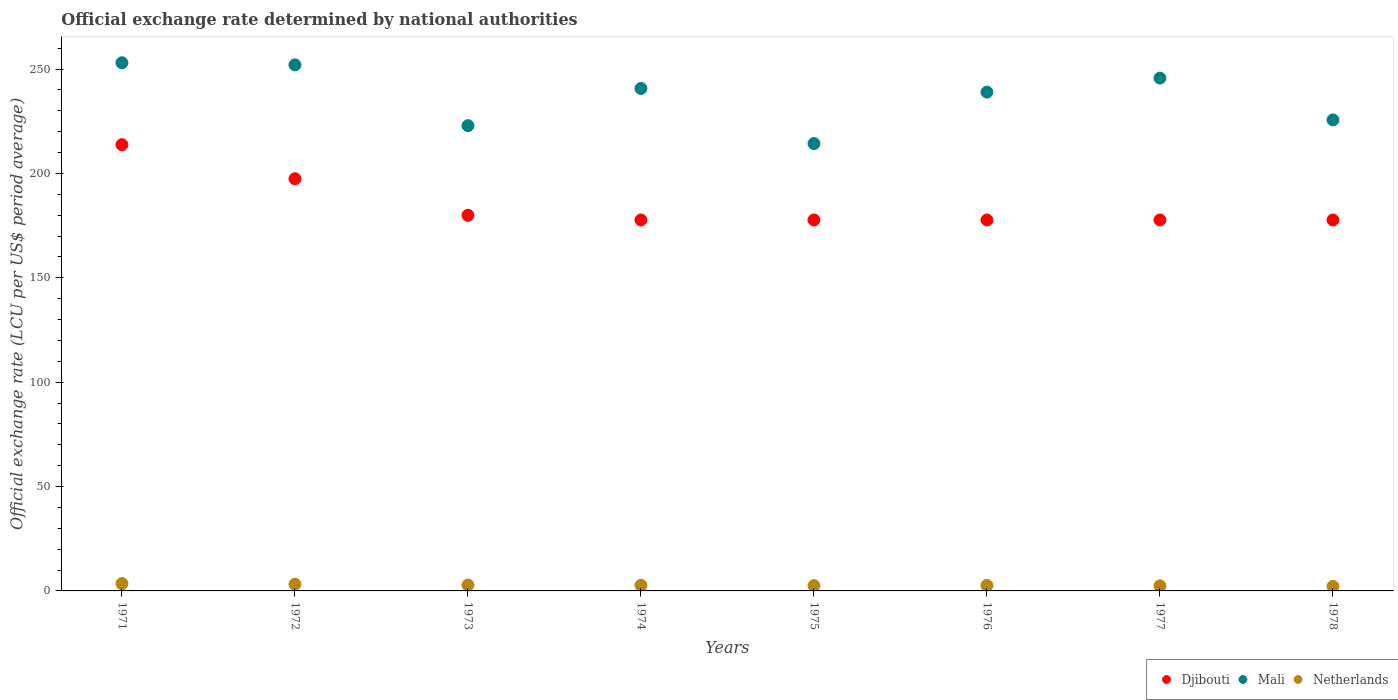How many different coloured dotlines are there?
Give a very brief answer. 3. What is the official exchange rate in Djibouti in 1975?
Make the answer very short. 177.72. Across all years, what is the maximum official exchange rate in Netherlands?
Provide a short and direct response. 3.52. Across all years, what is the minimum official exchange rate in Djibouti?
Ensure brevity in your answer.  177.72. In which year was the official exchange rate in Mali minimum?
Keep it short and to the point. 1975. What is the total official exchange rate in Netherlands in the graph?
Your response must be concise. 22. What is the difference between the official exchange rate in Djibouti in 1975 and the official exchange rate in Netherlands in 1974?
Make the answer very short. 175.03. What is the average official exchange rate in Netherlands per year?
Keep it short and to the point. 2.75. In the year 1971, what is the difference between the official exchange rate in Djibouti and official exchange rate in Netherlands?
Provide a short and direct response. 210.26. What is the ratio of the official exchange rate in Djibouti in 1972 to that in 1976?
Make the answer very short. 1.11. What is the difference between the highest and the second highest official exchange rate in Mali?
Ensure brevity in your answer.  1. What is the difference between the highest and the lowest official exchange rate in Djibouti?
Ensure brevity in your answer.  36.06. Is the sum of the official exchange rate in Djibouti in 1973 and 1977 greater than the maximum official exchange rate in Mali across all years?
Offer a very short reply. Yes. Does the official exchange rate in Netherlands monotonically increase over the years?
Keep it short and to the point. No. Is the official exchange rate in Mali strictly greater than the official exchange rate in Djibouti over the years?
Make the answer very short. Yes. Is the official exchange rate in Djibouti strictly less than the official exchange rate in Netherlands over the years?
Keep it short and to the point. No. How many years are there in the graph?
Provide a short and direct response. 8. What is the difference between two consecutive major ticks on the Y-axis?
Offer a terse response. 50. Does the graph contain any zero values?
Give a very brief answer. No. Does the graph contain grids?
Ensure brevity in your answer.  No. Where does the legend appear in the graph?
Your answer should be very brief. Bottom right. How many legend labels are there?
Your answer should be compact. 3. How are the legend labels stacked?
Your answer should be very brief. Horizontal. What is the title of the graph?
Keep it short and to the point. Official exchange rate determined by national authorities. What is the label or title of the X-axis?
Provide a short and direct response. Years. What is the label or title of the Y-axis?
Offer a very short reply. Official exchange rate (LCU per US$ period average). What is the Official exchange rate (LCU per US$ period average) in Djibouti in 1971?
Provide a succinct answer. 213.78. What is the Official exchange rate (LCU per US$ period average) of Mali in 1971?
Your answer should be very brief. 253.03. What is the Official exchange rate (LCU per US$ period average) of Netherlands in 1971?
Your answer should be compact. 3.52. What is the Official exchange rate (LCU per US$ period average) of Djibouti in 1972?
Ensure brevity in your answer.  197.47. What is the Official exchange rate (LCU per US$ period average) of Mali in 1972?
Provide a short and direct response. 252.03. What is the Official exchange rate (LCU per US$ period average) of Netherlands in 1972?
Provide a short and direct response. 3.21. What is the Official exchange rate (LCU per US$ period average) in Djibouti in 1973?
Ensure brevity in your answer.  179.94. What is the Official exchange rate (LCU per US$ period average) of Mali in 1973?
Give a very brief answer. 222.89. What is the Official exchange rate (LCU per US$ period average) of Netherlands in 1973?
Keep it short and to the point. 2.8. What is the Official exchange rate (LCU per US$ period average) of Djibouti in 1974?
Your response must be concise. 177.72. What is the Official exchange rate (LCU per US$ period average) of Mali in 1974?
Ensure brevity in your answer.  240.7. What is the Official exchange rate (LCU per US$ period average) in Netherlands in 1974?
Provide a succinct answer. 2.69. What is the Official exchange rate (LCU per US$ period average) of Djibouti in 1975?
Give a very brief answer. 177.72. What is the Official exchange rate (LCU per US$ period average) of Mali in 1975?
Your response must be concise. 214.31. What is the Official exchange rate (LCU per US$ period average) of Netherlands in 1975?
Your answer should be very brief. 2.53. What is the Official exchange rate (LCU per US$ period average) of Djibouti in 1976?
Your answer should be very brief. 177.72. What is the Official exchange rate (LCU per US$ period average) in Mali in 1976?
Give a very brief answer. 238.95. What is the Official exchange rate (LCU per US$ period average) of Netherlands in 1976?
Provide a succinct answer. 2.64. What is the Official exchange rate (LCU per US$ period average) in Djibouti in 1977?
Provide a succinct answer. 177.72. What is the Official exchange rate (LCU per US$ period average) of Mali in 1977?
Your answer should be compact. 245.68. What is the Official exchange rate (LCU per US$ period average) of Netherlands in 1977?
Provide a short and direct response. 2.45. What is the Official exchange rate (LCU per US$ period average) in Djibouti in 1978?
Give a very brief answer. 177.72. What is the Official exchange rate (LCU per US$ period average) of Mali in 1978?
Make the answer very short. 225.66. What is the Official exchange rate (LCU per US$ period average) of Netherlands in 1978?
Your response must be concise. 2.16. Across all years, what is the maximum Official exchange rate (LCU per US$ period average) of Djibouti?
Keep it short and to the point. 213.78. Across all years, what is the maximum Official exchange rate (LCU per US$ period average) in Mali?
Your answer should be very brief. 253.03. Across all years, what is the maximum Official exchange rate (LCU per US$ period average) of Netherlands?
Give a very brief answer. 3.52. Across all years, what is the minimum Official exchange rate (LCU per US$ period average) of Djibouti?
Ensure brevity in your answer.  177.72. Across all years, what is the minimum Official exchange rate (LCU per US$ period average) in Mali?
Offer a terse response. 214.31. Across all years, what is the minimum Official exchange rate (LCU per US$ period average) in Netherlands?
Offer a terse response. 2.16. What is the total Official exchange rate (LCU per US$ period average) of Djibouti in the graph?
Your answer should be very brief. 1479.79. What is the total Official exchange rate (LCU per US$ period average) of Mali in the graph?
Offer a terse response. 1893.25. What is the total Official exchange rate (LCU per US$ period average) of Netherlands in the graph?
Ensure brevity in your answer.  22. What is the difference between the Official exchange rate (LCU per US$ period average) of Djibouti in 1971 and that in 1972?
Ensure brevity in your answer.  16.31. What is the difference between the Official exchange rate (LCU per US$ period average) of Netherlands in 1971 and that in 1972?
Make the answer very short. 0.31. What is the difference between the Official exchange rate (LCU per US$ period average) in Djibouti in 1971 and that in 1973?
Your answer should be compact. 33.84. What is the difference between the Official exchange rate (LCU per US$ period average) of Mali in 1971 and that in 1973?
Keep it short and to the point. 30.14. What is the difference between the Official exchange rate (LCU per US$ period average) in Netherlands in 1971 and that in 1973?
Ensure brevity in your answer.  0.72. What is the difference between the Official exchange rate (LCU per US$ period average) of Djibouti in 1971 and that in 1974?
Make the answer very short. 36.06. What is the difference between the Official exchange rate (LCU per US$ period average) in Mali in 1971 and that in 1974?
Provide a short and direct response. 12.32. What is the difference between the Official exchange rate (LCU per US$ period average) in Netherlands in 1971 and that in 1974?
Provide a succinct answer. 0.83. What is the difference between the Official exchange rate (LCU per US$ period average) in Djibouti in 1971 and that in 1975?
Make the answer very short. 36.06. What is the difference between the Official exchange rate (LCU per US$ period average) of Mali in 1971 and that in 1975?
Offer a terse response. 38.71. What is the difference between the Official exchange rate (LCU per US$ period average) of Djibouti in 1971 and that in 1976?
Provide a short and direct response. 36.06. What is the difference between the Official exchange rate (LCU per US$ period average) in Mali in 1971 and that in 1976?
Offer a very short reply. 14.08. What is the difference between the Official exchange rate (LCU per US$ period average) in Netherlands in 1971 and that in 1976?
Provide a short and direct response. 0.87. What is the difference between the Official exchange rate (LCU per US$ period average) of Djibouti in 1971 and that in 1977?
Your response must be concise. 36.06. What is the difference between the Official exchange rate (LCU per US$ period average) in Mali in 1971 and that in 1977?
Offer a terse response. 7.35. What is the difference between the Official exchange rate (LCU per US$ period average) of Netherlands in 1971 and that in 1977?
Provide a succinct answer. 1.06. What is the difference between the Official exchange rate (LCU per US$ period average) of Djibouti in 1971 and that in 1978?
Your answer should be compact. 36.06. What is the difference between the Official exchange rate (LCU per US$ period average) of Mali in 1971 and that in 1978?
Your answer should be compact. 27.37. What is the difference between the Official exchange rate (LCU per US$ period average) in Netherlands in 1971 and that in 1978?
Your answer should be compact. 1.35. What is the difference between the Official exchange rate (LCU per US$ period average) of Djibouti in 1972 and that in 1973?
Make the answer very short. 17.52. What is the difference between the Official exchange rate (LCU per US$ period average) of Mali in 1972 and that in 1973?
Keep it short and to the point. 29.14. What is the difference between the Official exchange rate (LCU per US$ period average) in Netherlands in 1972 and that in 1973?
Offer a very short reply. 0.41. What is the difference between the Official exchange rate (LCU per US$ period average) in Djibouti in 1972 and that in 1974?
Give a very brief answer. 19.75. What is the difference between the Official exchange rate (LCU per US$ period average) of Mali in 1972 and that in 1974?
Your answer should be compact. 11.32. What is the difference between the Official exchange rate (LCU per US$ period average) in Netherlands in 1972 and that in 1974?
Provide a short and direct response. 0.52. What is the difference between the Official exchange rate (LCU per US$ period average) of Djibouti in 1972 and that in 1975?
Ensure brevity in your answer.  19.75. What is the difference between the Official exchange rate (LCU per US$ period average) in Mali in 1972 and that in 1975?
Your response must be concise. 37.71. What is the difference between the Official exchange rate (LCU per US$ period average) in Netherlands in 1972 and that in 1975?
Provide a succinct answer. 0.68. What is the difference between the Official exchange rate (LCU per US$ period average) of Djibouti in 1972 and that in 1976?
Make the answer very short. 19.75. What is the difference between the Official exchange rate (LCU per US$ period average) in Mali in 1972 and that in 1976?
Provide a short and direct response. 13.08. What is the difference between the Official exchange rate (LCU per US$ period average) of Netherlands in 1972 and that in 1976?
Your answer should be compact. 0.57. What is the difference between the Official exchange rate (LCU per US$ period average) in Djibouti in 1972 and that in 1977?
Provide a short and direct response. 19.75. What is the difference between the Official exchange rate (LCU per US$ period average) of Mali in 1972 and that in 1977?
Provide a succinct answer. 6.35. What is the difference between the Official exchange rate (LCU per US$ period average) in Netherlands in 1972 and that in 1977?
Provide a succinct answer. 0.76. What is the difference between the Official exchange rate (LCU per US$ period average) of Djibouti in 1972 and that in 1978?
Keep it short and to the point. 19.75. What is the difference between the Official exchange rate (LCU per US$ period average) of Mali in 1972 and that in 1978?
Offer a very short reply. 26.37. What is the difference between the Official exchange rate (LCU per US$ period average) in Netherlands in 1972 and that in 1978?
Keep it short and to the point. 1.05. What is the difference between the Official exchange rate (LCU per US$ period average) of Djibouti in 1973 and that in 1974?
Offer a very short reply. 2.22. What is the difference between the Official exchange rate (LCU per US$ period average) in Mali in 1973 and that in 1974?
Make the answer very short. -17.82. What is the difference between the Official exchange rate (LCU per US$ period average) in Netherlands in 1973 and that in 1974?
Your answer should be very brief. 0.11. What is the difference between the Official exchange rate (LCU per US$ period average) of Djibouti in 1973 and that in 1975?
Ensure brevity in your answer.  2.22. What is the difference between the Official exchange rate (LCU per US$ period average) in Mali in 1973 and that in 1975?
Offer a terse response. 8.58. What is the difference between the Official exchange rate (LCU per US$ period average) of Netherlands in 1973 and that in 1975?
Offer a terse response. 0.27. What is the difference between the Official exchange rate (LCU per US$ period average) in Djibouti in 1973 and that in 1976?
Offer a very short reply. 2.22. What is the difference between the Official exchange rate (LCU per US$ period average) of Mali in 1973 and that in 1976?
Provide a succinct answer. -16.06. What is the difference between the Official exchange rate (LCU per US$ period average) in Netherlands in 1973 and that in 1976?
Your answer should be compact. 0.15. What is the difference between the Official exchange rate (LCU per US$ period average) in Djibouti in 1973 and that in 1977?
Your answer should be compact. 2.22. What is the difference between the Official exchange rate (LCU per US$ period average) of Mali in 1973 and that in 1977?
Your answer should be very brief. -22.79. What is the difference between the Official exchange rate (LCU per US$ period average) in Netherlands in 1973 and that in 1977?
Provide a succinct answer. 0.34. What is the difference between the Official exchange rate (LCU per US$ period average) of Djibouti in 1973 and that in 1978?
Offer a terse response. 2.22. What is the difference between the Official exchange rate (LCU per US$ period average) in Mali in 1973 and that in 1978?
Offer a very short reply. -2.77. What is the difference between the Official exchange rate (LCU per US$ period average) of Netherlands in 1973 and that in 1978?
Offer a terse response. 0.63. What is the difference between the Official exchange rate (LCU per US$ period average) in Djibouti in 1974 and that in 1975?
Your answer should be compact. 0. What is the difference between the Official exchange rate (LCU per US$ period average) in Mali in 1974 and that in 1975?
Offer a terse response. 26.39. What is the difference between the Official exchange rate (LCU per US$ period average) of Netherlands in 1974 and that in 1975?
Ensure brevity in your answer.  0.16. What is the difference between the Official exchange rate (LCU per US$ period average) of Djibouti in 1974 and that in 1976?
Offer a terse response. 0. What is the difference between the Official exchange rate (LCU per US$ period average) in Mali in 1974 and that in 1976?
Make the answer very short. 1.75. What is the difference between the Official exchange rate (LCU per US$ period average) of Netherlands in 1974 and that in 1976?
Offer a very short reply. 0.04. What is the difference between the Official exchange rate (LCU per US$ period average) of Mali in 1974 and that in 1977?
Provide a succinct answer. -4.97. What is the difference between the Official exchange rate (LCU per US$ period average) of Netherlands in 1974 and that in 1977?
Your response must be concise. 0.23. What is the difference between the Official exchange rate (LCU per US$ period average) of Djibouti in 1974 and that in 1978?
Provide a short and direct response. 0. What is the difference between the Official exchange rate (LCU per US$ period average) of Mali in 1974 and that in 1978?
Ensure brevity in your answer.  15.05. What is the difference between the Official exchange rate (LCU per US$ period average) in Netherlands in 1974 and that in 1978?
Your answer should be compact. 0.52. What is the difference between the Official exchange rate (LCU per US$ period average) in Mali in 1975 and that in 1976?
Keep it short and to the point. -24.64. What is the difference between the Official exchange rate (LCU per US$ period average) in Netherlands in 1975 and that in 1976?
Your answer should be very brief. -0.11. What is the difference between the Official exchange rate (LCU per US$ period average) of Mali in 1975 and that in 1977?
Keep it short and to the point. -31.37. What is the difference between the Official exchange rate (LCU per US$ period average) in Netherlands in 1975 and that in 1977?
Ensure brevity in your answer.  0.07. What is the difference between the Official exchange rate (LCU per US$ period average) in Mali in 1975 and that in 1978?
Give a very brief answer. -11.34. What is the difference between the Official exchange rate (LCU per US$ period average) of Netherlands in 1975 and that in 1978?
Give a very brief answer. 0.37. What is the difference between the Official exchange rate (LCU per US$ period average) in Mali in 1976 and that in 1977?
Offer a very short reply. -6.73. What is the difference between the Official exchange rate (LCU per US$ period average) of Netherlands in 1976 and that in 1977?
Keep it short and to the point. 0.19. What is the difference between the Official exchange rate (LCU per US$ period average) of Djibouti in 1976 and that in 1978?
Offer a terse response. 0. What is the difference between the Official exchange rate (LCU per US$ period average) of Mali in 1976 and that in 1978?
Provide a succinct answer. 13.29. What is the difference between the Official exchange rate (LCU per US$ period average) in Netherlands in 1976 and that in 1978?
Make the answer very short. 0.48. What is the difference between the Official exchange rate (LCU per US$ period average) of Djibouti in 1977 and that in 1978?
Ensure brevity in your answer.  0. What is the difference between the Official exchange rate (LCU per US$ period average) of Mali in 1977 and that in 1978?
Offer a terse response. 20.02. What is the difference between the Official exchange rate (LCU per US$ period average) of Netherlands in 1977 and that in 1978?
Make the answer very short. 0.29. What is the difference between the Official exchange rate (LCU per US$ period average) of Djibouti in 1971 and the Official exchange rate (LCU per US$ period average) of Mali in 1972?
Your answer should be very brief. -38.25. What is the difference between the Official exchange rate (LCU per US$ period average) in Djibouti in 1971 and the Official exchange rate (LCU per US$ period average) in Netherlands in 1972?
Your answer should be very brief. 210.57. What is the difference between the Official exchange rate (LCU per US$ period average) of Mali in 1971 and the Official exchange rate (LCU per US$ period average) of Netherlands in 1972?
Offer a very short reply. 249.82. What is the difference between the Official exchange rate (LCU per US$ period average) of Djibouti in 1971 and the Official exchange rate (LCU per US$ period average) of Mali in 1973?
Keep it short and to the point. -9.11. What is the difference between the Official exchange rate (LCU per US$ period average) in Djibouti in 1971 and the Official exchange rate (LCU per US$ period average) in Netherlands in 1973?
Provide a succinct answer. 210.98. What is the difference between the Official exchange rate (LCU per US$ period average) in Mali in 1971 and the Official exchange rate (LCU per US$ period average) in Netherlands in 1973?
Give a very brief answer. 250.23. What is the difference between the Official exchange rate (LCU per US$ period average) in Djibouti in 1971 and the Official exchange rate (LCU per US$ period average) in Mali in 1974?
Provide a succinct answer. -26.93. What is the difference between the Official exchange rate (LCU per US$ period average) of Djibouti in 1971 and the Official exchange rate (LCU per US$ period average) of Netherlands in 1974?
Offer a terse response. 211.09. What is the difference between the Official exchange rate (LCU per US$ period average) in Mali in 1971 and the Official exchange rate (LCU per US$ period average) in Netherlands in 1974?
Give a very brief answer. 250.34. What is the difference between the Official exchange rate (LCU per US$ period average) of Djibouti in 1971 and the Official exchange rate (LCU per US$ period average) of Mali in 1975?
Your response must be concise. -0.53. What is the difference between the Official exchange rate (LCU per US$ period average) of Djibouti in 1971 and the Official exchange rate (LCU per US$ period average) of Netherlands in 1975?
Give a very brief answer. 211.25. What is the difference between the Official exchange rate (LCU per US$ period average) of Mali in 1971 and the Official exchange rate (LCU per US$ period average) of Netherlands in 1975?
Offer a terse response. 250.5. What is the difference between the Official exchange rate (LCU per US$ period average) of Djibouti in 1971 and the Official exchange rate (LCU per US$ period average) of Mali in 1976?
Your answer should be compact. -25.17. What is the difference between the Official exchange rate (LCU per US$ period average) in Djibouti in 1971 and the Official exchange rate (LCU per US$ period average) in Netherlands in 1976?
Your response must be concise. 211.13. What is the difference between the Official exchange rate (LCU per US$ period average) in Mali in 1971 and the Official exchange rate (LCU per US$ period average) in Netherlands in 1976?
Keep it short and to the point. 250.38. What is the difference between the Official exchange rate (LCU per US$ period average) in Djibouti in 1971 and the Official exchange rate (LCU per US$ period average) in Mali in 1977?
Keep it short and to the point. -31.9. What is the difference between the Official exchange rate (LCU per US$ period average) in Djibouti in 1971 and the Official exchange rate (LCU per US$ period average) in Netherlands in 1977?
Provide a succinct answer. 211.32. What is the difference between the Official exchange rate (LCU per US$ period average) of Mali in 1971 and the Official exchange rate (LCU per US$ period average) of Netherlands in 1977?
Give a very brief answer. 250.57. What is the difference between the Official exchange rate (LCU per US$ period average) of Djibouti in 1971 and the Official exchange rate (LCU per US$ period average) of Mali in 1978?
Ensure brevity in your answer.  -11.88. What is the difference between the Official exchange rate (LCU per US$ period average) in Djibouti in 1971 and the Official exchange rate (LCU per US$ period average) in Netherlands in 1978?
Ensure brevity in your answer.  211.62. What is the difference between the Official exchange rate (LCU per US$ period average) in Mali in 1971 and the Official exchange rate (LCU per US$ period average) in Netherlands in 1978?
Offer a terse response. 250.86. What is the difference between the Official exchange rate (LCU per US$ period average) of Djibouti in 1972 and the Official exchange rate (LCU per US$ period average) of Mali in 1973?
Offer a terse response. -25.42. What is the difference between the Official exchange rate (LCU per US$ period average) of Djibouti in 1972 and the Official exchange rate (LCU per US$ period average) of Netherlands in 1973?
Ensure brevity in your answer.  194.67. What is the difference between the Official exchange rate (LCU per US$ period average) of Mali in 1972 and the Official exchange rate (LCU per US$ period average) of Netherlands in 1973?
Make the answer very short. 249.23. What is the difference between the Official exchange rate (LCU per US$ period average) of Djibouti in 1972 and the Official exchange rate (LCU per US$ period average) of Mali in 1974?
Make the answer very short. -43.24. What is the difference between the Official exchange rate (LCU per US$ period average) of Djibouti in 1972 and the Official exchange rate (LCU per US$ period average) of Netherlands in 1974?
Ensure brevity in your answer.  194.78. What is the difference between the Official exchange rate (LCU per US$ period average) in Mali in 1972 and the Official exchange rate (LCU per US$ period average) in Netherlands in 1974?
Give a very brief answer. 249.34. What is the difference between the Official exchange rate (LCU per US$ period average) of Djibouti in 1972 and the Official exchange rate (LCU per US$ period average) of Mali in 1975?
Your answer should be compact. -16.85. What is the difference between the Official exchange rate (LCU per US$ period average) in Djibouti in 1972 and the Official exchange rate (LCU per US$ period average) in Netherlands in 1975?
Provide a short and direct response. 194.94. What is the difference between the Official exchange rate (LCU per US$ period average) of Mali in 1972 and the Official exchange rate (LCU per US$ period average) of Netherlands in 1975?
Offer a terse response. 249.5. What is the difference between the Official exchange rate (LCU per US$ period average) of Djibouti in 1972 and the Official exchange rate (LCU per US$ period average) of Mali in 1976?
Your answer should be very brief. -41.48. What is the difference between the Official exchange rate (LCU per US$ period average) in Djibouti in 1972 and the Official exchange rate (LCU per US$ period average) in Netherlands in 1976?
Offer a terse response. 194.82. What is the difference between the Official exchange rate (LCU per US$ period average) of Mali in 1972 and the Official exchange rate (LCU per US$ period average) of Netherlands in 1976?
Offer a very short reply. 249.38. What is the difference between the Official exchange rate (LCU per US$ period average) of Djibouti in 1972 and the Official exchange rate (LCU per US$ period average) of Mali in 1977?
Your answer should be compact. -48.21. What is the difference between the Official exchange rate (LCU per US$ period average) of Djibouti in 1972 and the Official exchange rate (LCU per US$ period average) of Netherlands in 1977?
Make the answer very short. 195.01. What is the difference between the Official exchange rate (LCU per US$ period average) in Mali in 1972 and the Official exchange rate (LCU per US$ period average) in Netherlands in 1977?
Provide a short and direct response. 249.57. What is the difference between the Official exchange rate (LCU per US$ period average) in Djibouti in 1972 and the Official exchange rate (LCU per US$ period average) in Mali in 1978?
Offer a very short reply. -28.19. What is the difference between the Official exchange rate (LCU per US$ period average) of Djibouti in 1972 and the Official exchange rate (LCU per US$ period average) of Netherlands in 1978?
Keep it short and to the point. 195.3. What is the difference between the Official exchange rate (LCU per US$ period average) of Mali in 1972 and the Official exchange rate (LCU per US$ period average) of Netherlands in 1978?
Make the answer very short. 249.86. What is the difference between the Official exchange rate (LCU per US$ period average) in Djibouti in 1973 and the Official exchange rate (LCU per US$ period average) in Mali in 1974?
Provide a short and direct response. -60.76. What is the difference between the Official exchange rate (LCU per US$ period average) in Djibouti in 1973 and the Official exchange rate (LCU per US$ period average) in Netherlands in 1974?
Provide a short and direct response. 177.25. What is the difference between the Official exchange rate (LCU per US$ period average) in Mali in 1973 and the Official exchange rate (LCU per US$ period average) in Netherlands in 1974?
Ensure brevity in your answer.  220.2. What is the difference between the Official exchange rate (LCU per US$ period average) of Djibouti in 1973 and the Official exchange rate (LCU per US$ period average) of Mali in 1975?
Offer a very short reply. -34.37. What is the difference between the Official exchange rate (LCU per US$ period average) of Djibouti in 1973 and the Official exchange rate (LCU per US$ period average) of Netherlands in 1975?
Provide a succinct answer. 177.41. What is the difference between the Official exchange rate (LCU per US$ period average) in Mali in 1973 and the Official exchange rate (LCU per US$ period average) in Netherlands in 1975?
Your response must be concise. 220.36. What is the difference between the Official exchange rate (LCU per US$ period average) in Djibouti in 1973 and the Official exchange rate (LCU per US$ period average) in Mali in 1976?
Keep it short and to the point. -59.01. What is the difference between the Official exchange rate (LCU per US$ period average) in Djibouti in 1973 and the Official exchange rate (LCU per US$ period average) in Netherlands in 1976?
Offer a very short reply. 177.3. What is the difference between the Official exchange rate (LCU per US$ period average) of Mali in 1973 and the Official exchange rate (LCU per US$ period average) of Netherlands in 1976?
Provide a succinct answer. 220.25. What is the difference between the Official exchange rate (LCU per US$ period average) of Djibouti in 1973 and the Official exchange rate (LCU per US$ period average) of Mali in 1977?
Offer a very short reply. -65.74. What is the difference between the Official exchange rate (LCU per US$ period average) in Djibouti in 1973 and the Official exchange rate (LCU per US$ period average) in Netherlands in 1977?
Give a very brief answer. 177.49. What is the difference between the Official exchange rate (LCU per US$ period average) in Mali in 1973 and the Official exchange rate (LCU per US$ period average) in Netherlands in 1977?
Ensure brevity in your answer.  220.43. What is the difference between the Official exchange rate (LCU per US$ period average) in Djibouti in 1973 and the Official exchange rate (LCU per US$ period average) in Mali in 1978?
Provide a short and direct response. -45.71. What is the difference between the Official exchange rate (LCU per US$ period average) of Djibouti in 1973 and the Official exchange rate (LCU per US$ period average) of Netherlands in 1978?
Keep it short and to the point. 177.78. What is the difference between the Official exchange rate (LCU per US$ period average) in Mali in 1973 and the Official exchange rate (LCU per US$ period average) in Netherlands in 1978?
Keep it short and to the point. 220.73. What is the difference between the Official exchange rate (LCU per US$ period average) of Djibouti in 1974 and the Official exchange rate (LCU per US$ period average) of Mali in 1975?
Your answer should be compact. -36.59. What is the difference between the Official exchange rate (LCU per US$ period average) in Djibouti in 1974 and the Official exchange rate (LCU per US$ period average) in Netherlands in 1975?
Ensure brevity in your answer.  175.19. What is the difference between the Official exchange rate (LCU per US$ period average) in Mali in 1974 and the Official exchange rate (LCU per US$ period average) in Netherlands in 1975?
Your answer should be compact. 238.18. What is the difference between the Official exchange rate (LCU per US$ period average) of Djibouti in 1974 and the Official exchange rate (LCU per US$ period average) of Mali in 1976?
Make the answer very short. -61.23. What is the difference between the Official exchange rate (LCU per US$ period average) in Djibouti in 1974 and the Official exchange rate (LCU per US$ period average) in Netherlands in 1976?
Ensure brevity in your answer.  175.08. What is the difference between the Official exchange rate (LCU per US$ period average) of Mali in 1974 and the Official exchange rate (LCU per US$ period average) of Netherlands in 1976?
Offer a very short reply. 238.06. What is the difference between the Official exchange rate (LCU per US$ period average) in Djibouti in 1974 and the Official exchange rate (LCU per US$ period average) in Mali in 1977?
Keep it short and to the point. -67.96. What is the difference between the Official exchange rate (LCU per US$ period average) of Djibouti in 1974 and the Official exchange rate (LCU per US$ period average) of Netherlands in 1977?
Offer a very short reply. 175.27. What is the difference between the Official exchange rate (LCU per US$ period average) of Mali in 1974 and the Official exchange rate (LCU per US$ period average) of Netherlands in 1977?
Your response must be concise. 238.25. What is the difference between the Official exchange rate (LCU per US$ period average) of Djibouti in 1974 and the Official exchange rate (LCU per US$ period average) of Mali in 1978?
Provide a succinct answer. -47.93. What is the difference between the Official exchange rate (LCU per US$ period average) of Djibouti in 1974 and the Official exchange rate (LCU per US$ period average) of Netherlands in 1978?
Your response must be concise. 175.56. What is the difference between the Official exchange rate (LCU per US$ period average) in Mali in 1974 and the Official exchange rate (LCU per US$ period average) in Netherlands in 1978?
Your answer should be very brief. 238.54. What is the difference between the Official exchange rate (LCU per US$ period average) in Djibouti in 1975 and the Official exchange rate (LCU per US$ period average) in Mali in 1976?
Give a very brief answer. -61.23. What is the difference between the Official exchange rate (LCU per US$ period average) of Djibouti in 1975 and the Official exchange rate (LCU per US$ period average) of Netherlands in 1976?
Keep it short and to the point. 175.08. What is the difference between the Official exchange rate (LCU per US$ period average) of Mali in 1975 and the Official exchange rate (LCU per US$ period average) of Netherlands in 1976?
Your answer should be compact. 211.67. What is the difference between the Official exchange rate (LCU per US$ period average) in Djibouti in 1975 and the Official exchange rate (LCU per US$ period average) in Mali in 1977?
Offer a very short reply. -67.96. What is the difference between the Official exchange rate (LCU per US$ period average) in Djibouti in 1975 and the Official exchange rate (LCU per US$ period average) in Netherlands in 1977?
Provide a succinct answer. 175.27. What is the difference between the Official exchange rate (LCU per US$ period average) of Mali in 1975 and the Official exchange rate (LCU per US$ period average) of Netherlands in 1977?
Keep it short and to the point. 211.86. What is the difference between the Official exchange rate (LCU per US$ period average) in Djibouti in 1975 and the Official exchange rate (LCU per US$ period average) in Mali in 1978?
Keep it short and to the point. -47.93. What is the difference between the Official exchange rate (LCU per US$ period average) of Djibouti in 1975 and the Official exchange rate (LCU per US$ period average) of Netherlands in 1978?
Ensure brevity in your answer.  175.56. What is the difference between the Official exchange rate (LCU per US$ period average) in Mali in 1975 and the Official exchange rate (LCU per US$ period average) in Netherlands in 1978?
Give a very brief answer. 212.15. What is the difference between the Official exchange rate (LCU per US$ period average) in Djibouti in 1976 and the Official exchange rate (LCU per US$ period average) in Mali in 1977?
Provide a succinct answer. -67.96. What is the difference between the Official exchange rate (LCU per US$ period average) of Djibouti in 1976 and the Official exchange rate (LCU per US$ period average) of Netherlands in 1977?
Give a very brief answer. 175.27. What is the difference between the Official exchange rate (LCU per US$ period average) of Mali in 1976 and the Official exchange rate (LCU per US$ period average) of Netherlands in 1977?
Your answer should be very brief. 236.5. What is the difference between the Official exchange rate (LCU per US$ period average) in Djibouti in 1976 and the Official exchange rate (LCU per US$ period average) in Mali in 1978?
Make the answer very short. -47.93. What is the difference between the Official exchange rate (LCU per US$ period average) of Djibouti in 1976 and the Official exchange rate (LCU per US$ period average) of Netherlands in 1978?
Your answer should be compact. 175.56. What is the difference between the Official exchange rate (LCU per US$ period average) of Mali in 1976 and the Official exchange rate (LCU per US$ period average) of Netherlands in 1978?
Give a very brief answer. 236.79. What is the difference between the Official exchange rate (LCU per US$ period average) of Djibouti in 1977 and the Official exchange rate (LCU per US$ period average) of Mali in 1978?
Your answer should be compact. -47.93. What is the difference between the Official exchange rate (LCU per US$ period average) in Djibouti in 1977 and the Official exchange rate (LCU per US$ period average) in Netherlands in 1978?
Offer a very short reply. 175.56. What is the difference between the Official exchange rate (LCU per US$ period average) of Mali in 1977 and the Official exchange rate (LCU per US$ period average) of Netherlands in 1978?
Provide a succinct answer. 243.52. What is the average Official exchange rate (LCU per US$ period average) in Djibouti per year?
Your response must be concise. 184.97. What is the average Official exchange rate (LCU per US$ period average) in Mali per year?
Provide a short and direct response. 236.66. What is the average Official exchange rate (LCU per US$ period average) in Netherlands per year?
Offer a very short reply. 2.75. In the year 1971, what is the difference between the Official exchange rate (LCU per US$ period average) in Djibouti and Official exchange rate (LCU per US$ period average) in Mali?
Make the answer very short. -39.25. In the year 1971, what is the difference between the Official exchange rate (LCU per US$ period average) of Djibouti and Official exchange rate (LCU per US$ period average) of Netherlands?
Provide a short and direct response. 210.26. In the year 1971, what is the difference between the Official exchange rate (LCU per US$ period average) in Mali and Official exchange rate (LCU per US$ period average) in Netherlands?
Your response must be concise. 249.51. In the year 1972, what is the difference between the Official exchange rate (LCU per US$ period average) of Djibouti and Official exchange rate (LCU per US$ period average) of Mali?
Your answer should be very brief. -54.56. In the year 1972, what is the difference between the Official exchange rate (LCU per US$ period average) of Djibouti and Official exchange rate (LCU per US$ period average) of Netherlands?
Give a very brief answer. 194.26. In the year 1972, what is the difference between the Official exchange rate (LCU per US$ period average) in Mali and Official exchange rate (LCU per US$ period average) in Netherlands?
Provide a short and direct response. 248.82. In the year 1973, what is the difference between the Official exchange rate (LCU per US$ period average) of Djibouti and Official exchange rate (LCU per US$ period average) of Mali?
Your answer should be compact. -42.95. In the year 1973, what is the difference between the Official exchange rate (LCU per US$ period average) in Djibouti and Official exchange rate (LCU per US$ period average) in Netherlands?
Keep it short and to the point. 177.15. In the year 1973, what is the difference between the Official exchange rate (LCU per US$ period average) of Mali and Official exchange rate (LCU per US$ period average) of Netherlands?
Keep it short and to the point. 220.09. In the year 1974, what is the difference between the Official exchange rate (LCU per US$ period average) in Djibouti and Official exchange rate (LCU per US$ period average) in Mali?
Offer a terse response. -62.98. In the year 1974, what is the difference between the Official exchange rate (LCU per US$ period average) of Djibouti and Official exchange rate (LCU per US$ period average) of Netherlands?
Offer a very short reply. 175.03. In the year 1974, what is the difference between the Official exchange rate (LCU per US$ period average) of Mali and Official exchange rate (LCU per US$ period average) of Netherlands?
Make the answer very short. 238.02. In the year 1975, what is the difference between the Official exchange rate (LCU per US$ period average) in Djibouti and Official exchange rate (LCU per US$ period average) in Mali?
Your response must be concise. -36.59. In the year 1975, what is the difference between the Official exchange rate (LCU per US$ period average) of Djibouti and Official exchange rate (LCU per US$ period average) of Netherlands?
Provide a short and direct response. 175.19. In the year 1975, what is the difference between the Official exchange rate (LCU per US$ period average) in Mali and Official exchange rate (LCU per US$ period average) in Netherlands?
Your answer should be very brief. 211.78. In the year 1976, what is the difference between the Official exchange rate (LCU per US$ period average) in Djibouti and Official exchange rate (LCU per US$ period average) in Mali?
Ensure brevity in your answer.  -61.23. In the year 1976, what is the difference between the Official exchange rate (LCU per US$ period average) of Djibouti and Official exchange rate (LCU per US$ period average) of Netherlands?
Your answer should be very brief. 175.08. In the year 1976, what is the difference between the Official exchange rate (LCU per US$ period average) in Mali and Official exchange rate (LCU per US$ period average) in Netherlands?
Your response must be concise. 236.31. In the year 1977, what is the difference between the Official exchange rate (LCU per US$ period average) in Djibouti and Official exchange rate (LCU per US$ period average) in Mali?
Offer a terse response. -67.96. In the year 1977, what is the difference between the Official exchange rate (LCU per US$ period average) in Djibouti and Official exchange rate (LCU per US$ period average) in Netherlands?
Give a very brief answer. 175.27. In the year 1977, what is the difference between the Official exchange rate (LCU per US$ period average) of Mali and Official exchange rate (LCU per US$ period average) of Netherlands?
Give a very brief answer. 243.23. In the year 1978, what is the difference between the Official exchange rate (LCU per US$ period average) in Djibouti and Official exchange rate (LCU per US$ period average) in Mali?
Your response must be concise. -47.93. In the year 1978, what is the difference between the Official exchange rate (LCU per US$ period average) in Djibouti and Official exchange rate (LCU per US$ period average) in Netherlands?
Give a very brief answer. 175.56. In the year 1978, what is the difference between the Official exchange rate (LCU per US$ period average) of Mali and Official exchange rate (LCU per US$ period average) of Netherlands?
Make the answer very short. 223.49. What is the ratio of the Official exchange rate (LCU per US$ period average) of Djibouti in 1971 to that in 1972?
Keep it short and to the point. 1.08. What is the ratio of the Official exchange rate (LCU per US$ period average) of Netherlands in 1971 to that in 1972?
Your answer should be very brief. 1.1. What is the ratio of the Official exchange rate (LCU per US$ period average) of Djibouti in 1971 to that in 1973?
Keep it short and to the point. 1.19. What is the ratio of the Official exchange rate (LCU per US$ period average) of Mali in 1971 to that in 1973?
Your answer should be compact. 1.14. What is the ratio of the Official exchange rate (LCU per US$ period average) in Netherlands in 1971 to that in 1973?
Your answer should be compact. 1.26. What is the ratio of the Official exchange rate (LCU per US$ period average) in Djibouti in 1971 to that in 1974?
Offer a terse response. 1.2. What is the ratio of the Official exchange rate (LCU per US$ period average) of Mali in 1971 to that in 1974?
Your answer should be very brief. 1.05. What is the ratio of the Official exchange rate (LCU per US$ period average) of Netherlands in 1971 to that in 1974?
Offer a very short reply. 1.31. What is the ratio of the Official exchange rate (LCU per US$ period average) in Djibouti in 1971 to that in 1975?
Make the answer very short. 1.2. What is the ratio of the Official exchange rate (LCU per US$ period average) of Mali in 1971 to that in 1975?
Keep it short and to the point. 1.18. What is the ratio of the Official exchange rate (LCU per US$ period average) of Netherlands in 1971 to that in 1975?
Provide a short and direct response. 1.39. What is the ratio of the Official exchange rate (LCU per US$ period average) in Djibouti in 1971 to that in 1976?
Offer a very short reply. 1.2. What is the ratio of the Official exchange rate (LCU per US$ period average) in Mali in 1971 to that in 1976?
Make the answer very short. 1.06. What is the ratio of the Official exchange rate (LCU per US$ period average) in Netherlands in 1971 to that in 1976?
Give a very brief answer. 1.33. What is the ratio of the Official exchange rate (LCU per US$ period average) of Djibouti in 1971 to that in 1977?
Your answer should be compact. 1.2. What is the ratio of the Official exchange rate (LCU per US$ period average) in Mali in 1971 to that in 1977?
Provide a short and direct response. 1.03. What is the ratio of the Official exchange rate (LCU per US$ period average) of Netherlands in 1971 to that in 1977?
Make the answer very short. 1.43. What is the ratio of the Official exchange rate (LCU per US$ period average) of Djibouti in 1971 to that in 1978?
Offer a very short reply. 1.2. What is the ratio of the Official exchange rate (LCU per US$ period average) in Mali in 1971 to that in 1978?
Ensure brevity in your answer.  1.12. What is the ratio of the Official exchange rate (LCU per US$ period average) in Netherlands in 1971 to that in 1978?
Offer a very short reply. 1.63. What is the ratio of the Official exchange rate (LCU per US$ period average) of Djibouti in 1972 to that in 1973?
Make the answer very short. 1.1. What is the ratio of the Official exchange rate (LCU per US$ period average) in Mali in 1972 to that in 1973?
Your answer should be compact. 1.13. What is the ratio of the Official exchange rate (LCU per US$ period average) of Netherlands in 1972 to that in 1973?
Your response must be concise. 1.15. What is the ratio of the Official exchange rate (LCU per US$ period average) in Mali in 1972 to that in 1974?
Offer a very short reply. 1.05. What is the ratio of the Official exchange rate (LCU per US$ period average) of Netherlands in 1972 to that in 1974?
Your response must be concise. 1.19. What is the ratio of the Official exchange rate (LCU per US$ period average) in Djibouti in 1972 to that in 1975?
Your response must be concise. 1.11. What is the ratio of the Official exchange rate (LCU per US$ period average) in Mali in 1972 to that in 1975?
Offer a very short reply. 1.18. What is the ratio of the Official exchange rate (LCU per US$ period average) of Netherlands in 1972 to that in 1975?
Ensure brevity in your answer.  1.27. What is the ratio of the Official exchange rate (LCU per US$ period average) of Mali in 1972 to that in 1976?
Provide a short and direct response. 1.05. What is the ratio of the Official exchange rate (LCU per US$ period average) of Netherlands in 1972 to that in 1976?
Your answer should be very brief. 1.21. What is the ratio of the Official exchange rate (LCU per US$ period average) of Djibouti in 1972 to that in 1977?
Your answer should be very brief. 1.11. What is the ratio of the Official exchange rate (LCU per US$ period average) of Mali in 1972 to that in 1977?
Your answer should be compact. 1.03. What is the ratio of the Official exchange rate (LCU per US$ period average) in Netherlands in 1972 to that in 1977?
Make the answer very short. 1.31. What is the ratio of the Official exchange rate (LCU per US$ period average) in Djibouti in 1972 to that in 1978?
Your answer should be very brief. 1.11. What is the ratio of the Official exchange rate (LCU per US$ period average) in Mali in 1972 to that in 1978?
Ensure brevity in your answer.  1.12. What is the ratio of the Official exchange rate (LCU per US$ period average) of Netherlands in 1972 to that in 1978?
Offer a very short reply. 1.48. What is the ratio of the Official exchange rate (LCU per US$ period average) of Djibouti in 1973 to that in 1974?
Your response must be concise. 1.01. What is the ratio of the Official exchange rate (LCU per US$ period average) of Mali in 1973 to that in 1974?
Your response must be concise. 0.93. What is the ratio of the Official exchange rate (LCU per US$ period average) in Netherlands in 1973 to that in 1974?
Give a very brief answer. 1.04. What is the ratio of the Official exchange rate (LCU per US$ period average) of Djibouti in 1973 to that in 1975?
Offer a very short reply. 1.01. What is the ratio of the Official exchange rate (LCU per US$ period average) of Netherlands in 1973 to that in 1975?
Provide a short and direct response. 1.11. What is the ratio of the Official exchange rate (LCU per US$ period average) in Djibouti in 1973 to that in 1976?
Offer a very short reply. 1.01. What is the ratio of the Official exchange rate (LCU per US$ period average) in Mali in 1973 to that in 1976?
Ensure brevity in your answer.  0.93. What is the ratio of the Official exchange rate (LCU per US$ period average) in Netherlands in 1973 to that in 1976?
Provide a succinct answer. 1.06. What is the ratio of the Official exchange rate (LCU per US$ period average) of Djibouti in 1973 to that in 1977?
Offer a very short reply. 1.01. What is the ratio of the Official exchange rate (LCU per US$ period average) of Mali in 1973 to that in 1977?
Offer a terse response. 0.91. What is the ratio of the Official exchange rate (LCU per US$ period average) in Netherlands in 1973 to that in 1977?
Give a very brief answer. 1.14. What is the ratio of the Official exchange rate (LCU per US$ period average) of Djibouti in 1973 to that in 1978?
Your answer should be compact. 1.01. What is the ratio of the Official exchange rate (LCU per US$ period average) in Netherlands in 1973 to that in 1978?
Make the answer very short. 1.29. What is the ratio of the Official exchange rate (LCU per US$ period average) in Djibouti in 1974 to that in 1975?
Your answer should be compact. 1. What is the ratio of the Official exchange rate (LCU per US$ period average) of Mali in 1974 to that in 1975?
Offer a very short reply. 1.12. What is the ratio of the Official exchange rate (LCU per US$ period average) in Netherlands in 1974 to that in 1975?
Your response must be concise. 1.06. What is the ratio of the Official exchange rate (LCU per US$ period average) of Mali in 1974 to that in 1976?
Offer a terse response. 1.01. What is the ratio of the Official exchange rate (LCU per US$ period average) of Netherlands in 1974 to that in 1976?
Offer a very short reply. 1.02. What is the ratio of the Official exchange rate (LCU per US$ period average) of Djibouti in 1974 to that in 1977?
Your answer should be very brief. 1. What is the ratio of the Official exchange rate (LCU per US$ period average) in Mali in 1974 to that in 1977?
Your answer should be very brief. 0.98. What is the ratio of the Official exchange rate (LCU per US$ period average) of Netherlands in 1974 to that in 1977?
Your answer should be very brief. 1.1. What is the ratio of the Official exchange rate (LCU per US$ period average) in Mali in 1974 to that in 1978?
Offer a very short reply. 1.07. What is the ratio of the Official exchange rate (LCU per US$ period average) in Netherlands in 1974 to that in 1978?
Ensure brevity in your answer.  1.24. What is the ratio of the Official exchange rate (LCU per US$ period average) in Mali in 1975 to that in 1976?
Keep it short and to the point. 0.9. What is the ratio of the Official exchange rate (LCU per US$ period average) of Netherlands in 1975 to that in 1976?
Provide a succinct answer. 0.96. What is the ratio of the Official exchange rate (LCU per US$ period average) of Djibouti in 1975 to that in 1977?
Offer a terse response. 1. What is the ratio of the Official exchange rate (LCU per US$ period average) of Mali in 1975 to that in 1977?
Ensure brevity in your answer.  0.87. What is the ratio of the Official exchange rate (LCU per US$ period average) in Netherlands in 1975 to that in 1977?
Provide a short and direct response. 1.03. What is the ratio of the Official exchange rate (LCU per US$ period average) of Djibouti in 1975 to that in 1978?
Give a very brief answer. 1. What is the ratio of the Official exchange rate (LCU per US$ period average) of Mali in 1975 to that in 1978?
Offer a very short reply. 0.95. What is the ratio of the Official exchange rate (LCU per US$ period average) of Netherlands in 1975 to that in 1978?
Your response must be concise. 1.17. What is the ratio of the Official exchange rate (LCU per US$ period average) in Mali in 1976 to that in 1977?
Offer a terse response. 0.97. What is the ratio of the Official exchange rate (LCU per US$ period average) in Netherlands in 1976 to that in 1977?
Offer a very short reply. 1.08. What is the ratio of the Official exchange rate (LCU per US$ period average) of Djibouti in 1976 to that in 1978?
Offer a terse response. 1. What is the ratio of the Official exchange rate (LCU per US$ period average) in Mali in 1976 to that in 1978?
Provide a short and direct response. 1.06. What is the ratio of the Official exchange rate (LCU per US$ period average) in Netherlands in 1976 to that in 1978?
Keep it short and to the point. 1.22. What is the ratio of the Official exchange rate (LCU per US$ period average) in Mali in 1977 to that in 1978?
Your answer should be compact. 1.09. What is the ratio of the Official exchange rate (LCU per US$ period average) in Netherlands in 1977 to that in 1978?
Ensure brevity in your answer.  1.13. What is the difference between the highest and the second highest Official exchange rate (LCU per US$ period average) of Djibouti?
Provide a short and direct response. 16.31. What is the difference between the highest and the second highest Official exchange rate (LCU per US$ period average) of Netherlands?
Provide a short and direct response. 0.31. What is the difference between the highest and the lowest Official exchange rate (LCU per US$ period average) in Djibouti?
Provide a succinct answer. 36.06. What is the difference between the highest and the lowest Official exchange rate (LCU per US$ period average) in Mali?
Keep it short and to the point. 38.71. What is the difference between the highest and the lowest Official exchange rate (LCU per US$ period average) of Netherlands?
Offer a terse response. 1.35. 